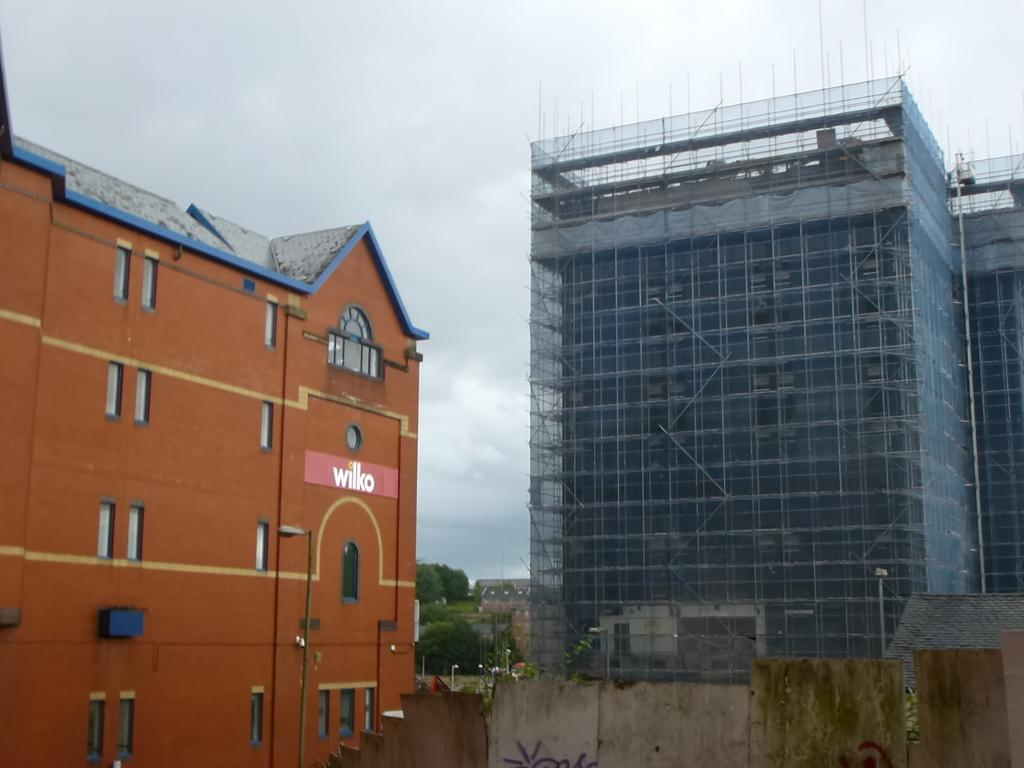What type of structures can be seen in the image? There are houses, light poles, trees, and a building under construction in the image. What is the purpose of the light poles in the image? The light poles are likely used for illuminating the area at night. What is the status of the building in the image? The building is under construction in the image. What type of barrier is present in the image? There is a wall in the image. What can be seen in the background of the image? The sky is visible in the background of the image, and it appears to be cloudy. What type of transport is depicted in the image? There is no transport visible in the image; it primarily features structures and objects. What type of thrill can be experienced by the houses in the image? Houses do not experience thrills; they are inanimate objects. 